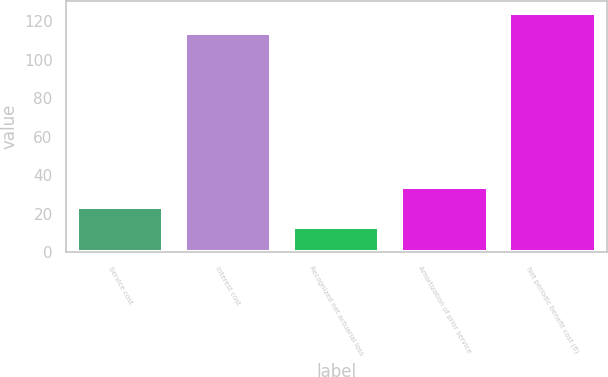Convert chart to OTSL. <chart><loc_0><loc_0><loc_500><loc_500><bar_chart><fcel>Service cost<fcel>Interest cost<fcel>Recognized net actuarial loss<fcel>Amortization of prior service<fcel>Net periodic benefit cost (6)<nl><fcel>23.4<fcel>114<fcel>13<fcel>33.8<fcel>124.4<nl></chart> 